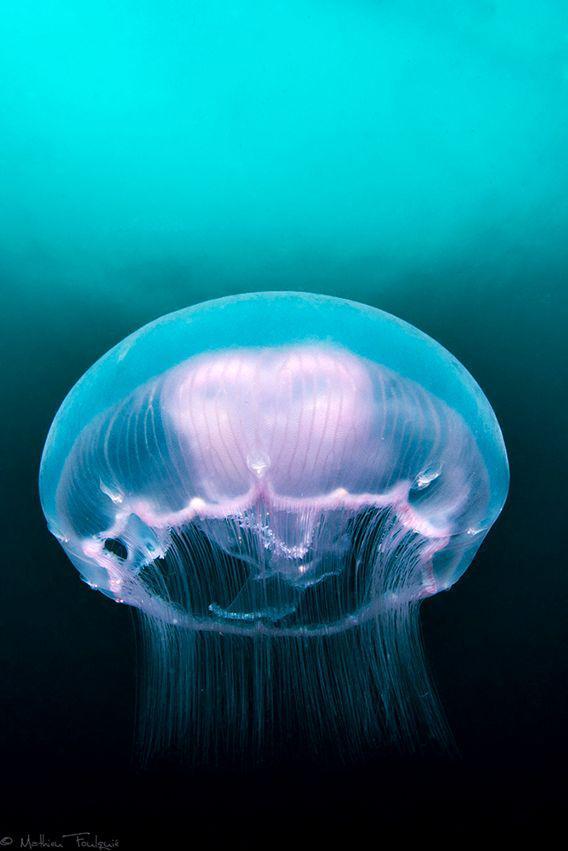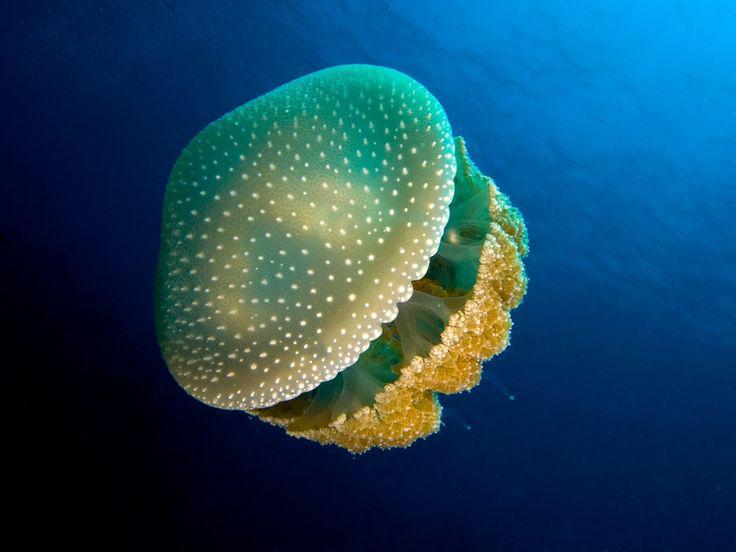The first image is the image on the left, the second image is the image on the right. Assess this claim about the two images: "At least one jellyfish has long, stringy tentacles.". Correct or not? Answer yes or no. No. The first image is the image on the left, the second image is the image on the right. For the images shown, is this caption "The jellyfish on the right is yellowish, with a rounded top and a cauliflower-like bottom without long tendrils." true? Answer yes or no. Yes. 